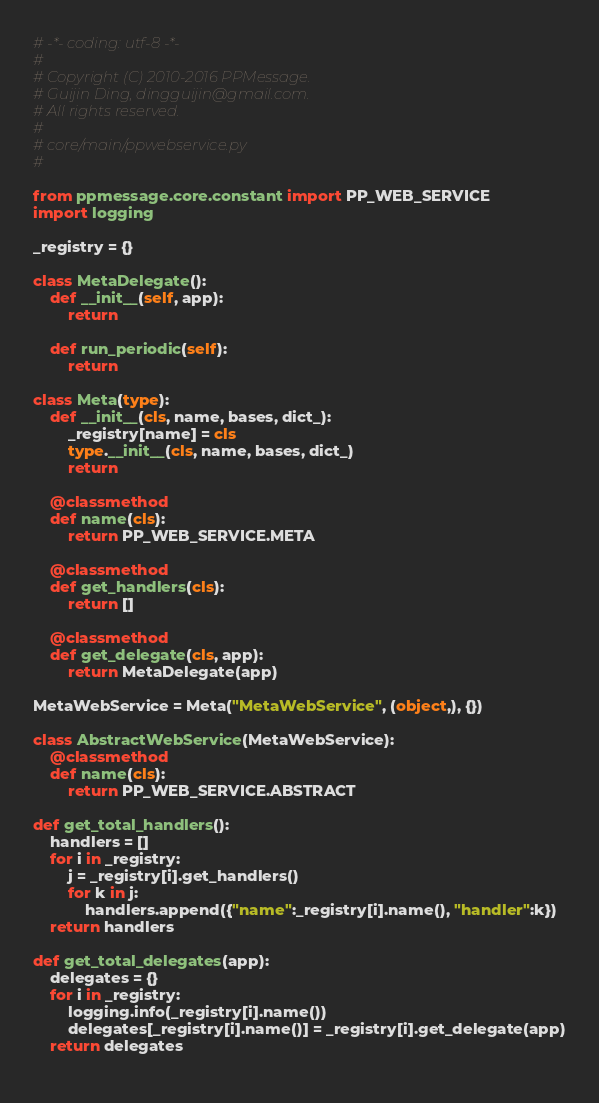<code> <loc_0><loc_0><loc_500><loc_500><_Python_># -*- coding: utf-8 -*-
#
# Copyright (C) 2010-2016 PPMessage.
# Guijin Ding, dingguijin@gmail.com.
# All rights reserved.
#
# core/main/ppwebservice.py
#

from ppmessage.core.constant import PP_WEB_SERVICE
import logging

_registry = {}

class MetaDelegate():
    def __init__(self, app):
        return
    
    def run_periodic(self):
        return

class Meta(type):
    def __init__(cls, name, bases, dict_):
        _registry[name] = cls
        type.__init__(cls, name, bases, dict_)
        return

    @classmethod
    def name(cls):
        return PP_WEB_SERVICE.META

    @classmethod
    def get_handlers(cls):
        return []

    @classmethod
    def get_delegate(cls, app):
        return MetaDelegate(app)
    
MetaWebService = Meta("MetaWebService", (object,), {})

class AbstractWebService(MetaWebService):
    @classmethod
    def name(cls):
        return PP_WEB_SERVICE.ABSTRACT

def get_total_handlers():
    handlers = []
    for i in _registry:
        j = _registry[i].get_handlers()
        for k in j:
            handlers.append({"name":_registry[i].name(), "handler":k})
    return handlers

def get_total_delegates(app):
    delegates = {}
    for i in _registry:
        logging.info(_registry[i].name())
        delegates[_registry[i].name()] = _registry[i].get_delegate(app)
    return delegates
    

</code> 